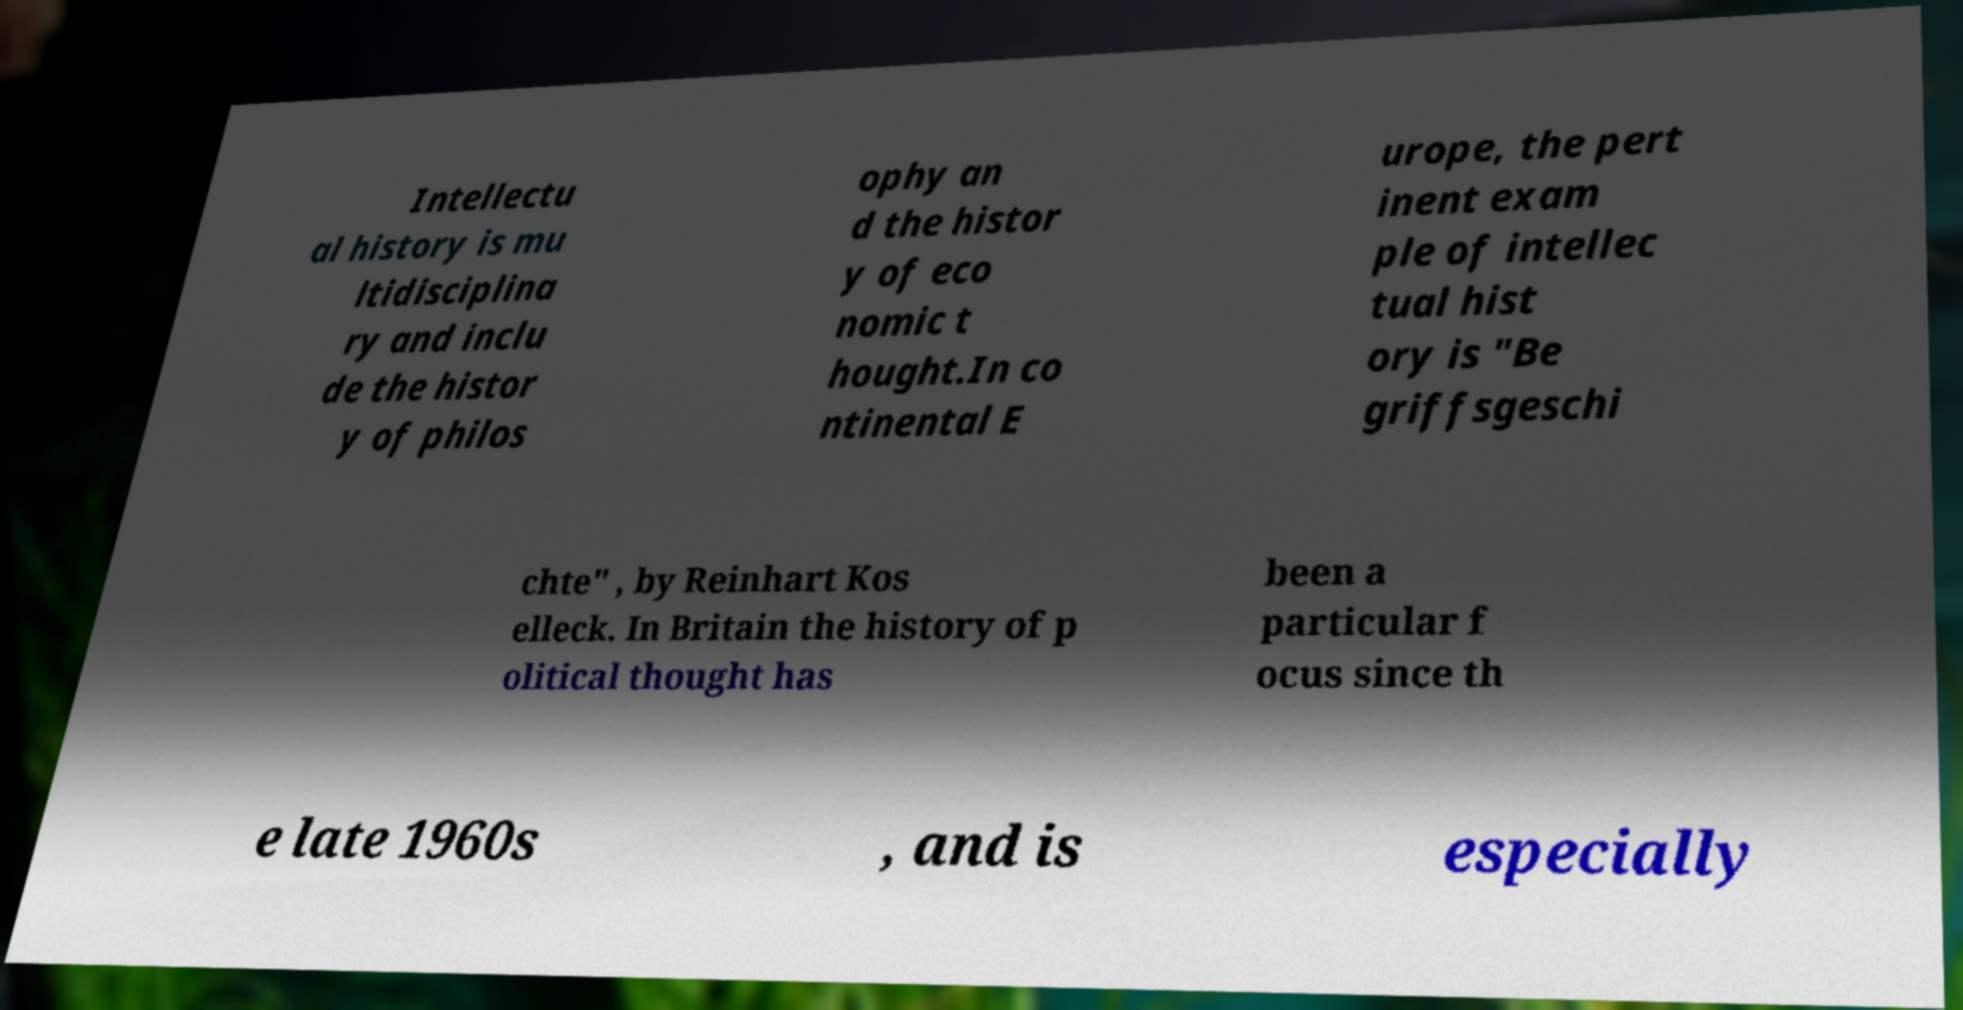There's text embedded in this image that I need extracted. Can you transcribe it verbatim? Intellectu al history is mu ltidisciplina ry and inclu de the histor y of philos ophy an d the histor y of eco nomic t hought.In co ntinental E urope, the pert inent exam ple of intellec tual hist ory is "Be griffsgeschi chte" , by Reinhart Kos elleck. In Britain the history of p olitical thought has been a particular f ocus since th e late 1960s , and is especially 